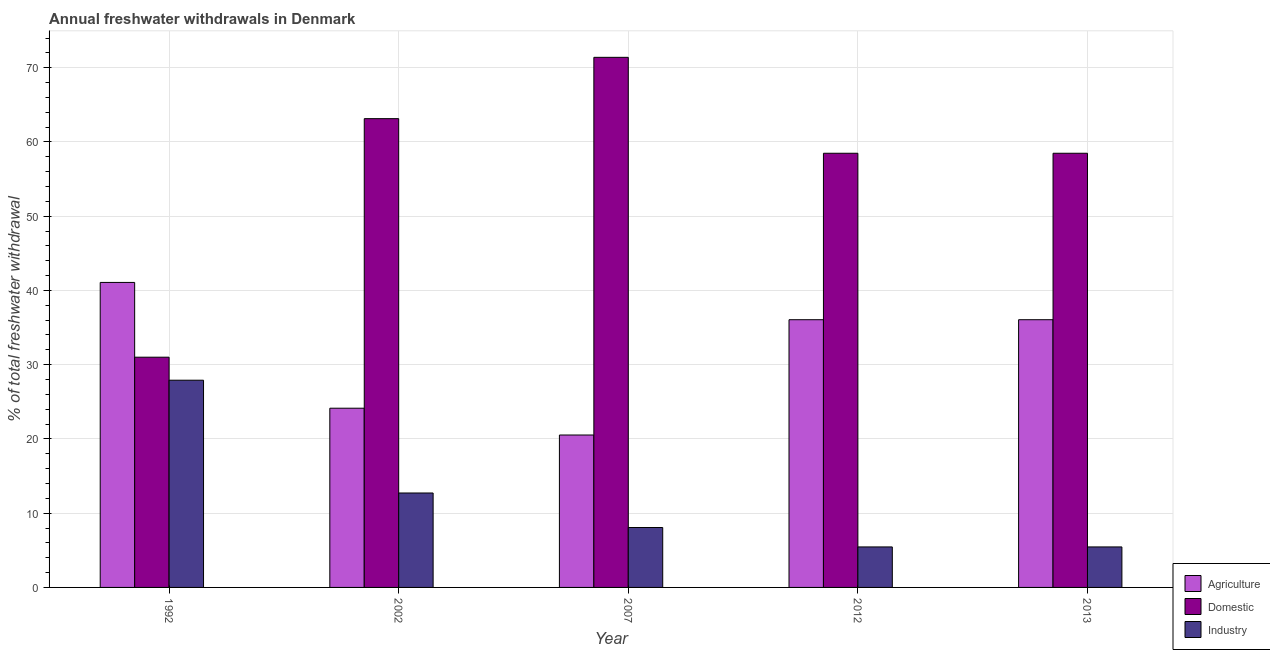How many groups of bars are there?
Provide a succinct answer. 5. Are the number of bars on each tick of the X-axis equal?
Ensure brevity in your answer.  Yes. How many bars are there on the 4th tick from the left?
Your answer should be very brief. 3. What is the label of the 1st group of bars from the left?
Your response must be concise. 1992. In how many cases, is the number of bars for a given year not equal to the number of legend labels?
Provide a succinct answer. 0. What is the percentage of freshwater withdrawal for agriculture in 2002?
Ensure brevity in your answer.  24.14. Across all years, what is the maximum percentage of freshwater withdrawal for agriculture?
Your response must be concise. 41.08. Across all years, what is the minimum percentage of freshwater withdrawal for domestic purposes?
Offer a very short reply. 31.01. In which year was the percentage of freshwater withdrawal for industry maximum?
Give a very brief answer. 1992. In which year was the percentage of freshwater withdrawal for agriculture minimum?
Offer a terse response. 2007. What is the total percentage of freshwater withdrawal for industry in the graph?
Give a very brief answer. 59.61. What is the difference between the percentage of freshwater withdrawal for domestic purposes in 2002 and that in 2012?
Ensure brevity in your answer.  4.66. What is the difference between the percentage of freshwater withdrawal for agriculture in 1992 and the percentage of freshwater withdrawal for domestic purposes in 2012?
Make the answer very short. 5.02. What is the average percentage of freshwater withdrawal for industry per year?
Give a very brief answer. 11.92. What is the ratio of the percentage of freshwater withdrawal for industry in 2007 to that in 2013?
Your response must be concise. 1.48. Is the difference between the percentage of freshwater withdrawal for agriculture in 2002 and 2013 greater than the difference between the percentage of freshwater withdrawal for industry in 2002 and 2013?
Offer a terse response. No. What is the difference between the highest and the second highest percentage of freshwater withdrawal for industry?
Keep it short and to the point. 15.19. What is the difference between the highest and the lowest percentage of freshwater withdrawal for industry?
Your answer should be compact. 22.45. What does the 3rd bar from the left in 2013 represents?
Provide a short and direct response. Industry. What does the 3rd bar from the right in 2002 represents?
Ensure brevity in your answer.  Agriculture. How many bars are there?
Provide a short and direct response. 15. Are all the bars in the graph horizontal?
Provide a succinct answer. No. How many years are there in the graph?
Offer a terse response. 5. Are the values on the major ticks of Y-axis written in scientific E-notation?
Your response must be concise. No. Does the graph contain grids?
Make the answer very short. Yes. Where does the legend appear in the graph?
Make the answer very short. Bottom right. How many legend labels are there?
Provide a short and direct response. 3. What is the title of the graph?
Give a very brief answer. Annual freshwater withdrawals in Denmark. Does "Non-communicable diseases" appear as one of the legend labels in the graph?
Give a very brief answer. No. What is the label or title of the Y-axis?
Provide a short and direct response. % of total freshwater withdrawal. What is the % of total freshwater withdrawal in Agriculture in 1992?
Provide a succinct answer. 41.08. What is the % of total freshwater withdrawal of Domestic in 1992?
Offer a terse response. 31.01. What is the % of total freshwater withdrawal of Industry in 1992?
Ensure brevity in your answer.  27.91. What is the % of total freshwater withdrawal in Agriculture in 2002?
Offer a terse response. 24.14. What is the % of total freshwater withdrawal of Domestic in 2002?
Offer a terse response. 63.14. What is the % of total freshwater withdrawal of Industry in 2002?
Offer a terse response. 12.72. What is the % of total freshwater withdrawal of Agriculture in 2007?
Provide a short and direct response. 20.53. What is the % of total freshwater withdrawal in Domestic in 2007?
Ensure brevity in your answer.  71.4. What is the % of total freshwater withdrawal in Industry in 2007?
Make the answer very short. 8.07. What is the % of total freshwater withdrawal of Agriculture in 2012?
Provide a succinct answer. 36.06. What is the % of total freshwater withdrawal of Domestic in 2012?
Make the answer very short. 58.48. What is the % of total freshwater withdrawal of Industry in 2012?
Provide a succinct answer. 5.46. What is the % of total freshwater withdrawal in Agriculture in 2013?
Your answer should be compact. 36.06. What is the % of total freshwater withdrawal of Domestic in 2013?
Offer a terse response. 58.48. What is the % of total freshwater withdrawal of Industry in 2013?
Offer a very short reply. 5.46. Across all years, what is the maximum % of total freshwater withdrawal of Agriculture?
Offer a very short reply. 41.08. Across all years, what is the maximum % of total freshwater withdrawal of Domestic?
Your answer should be compact. 71.4. Across all years, what is the maximum % of total freshwater withdrawal in Industry?
Make the answer very short. 27.91. Across all years, what is the minimum % of total freshwater withdrawal in Agriculture?
Keep it short and to the point. 20.53. Across all years, what is the minimum % of total freshwater withdrawal in Domestic?
Your response must be concise. 31.01. Across all years, what is the minimum % of total freshwater withdrawal of Industry?
Offer a very short reply. 5.46. What is the total % of total freshwater withdrawal in Agriculture in the graph?
Ensure brevity in your answer.  157.87. What is the total % of total freshwater withdrawal of Domestic in the graph?
Offer a very short reply. 282.51. What is the total % of total freshwater withdrawal in Industry in the graph?
Offer a very short reply. 59.61. What is the difference between the % of total freshwater withdrawal in Agriculture in 1992 and that in 2002?
Your response must be concise. 16.94. What is the difference between the % of total freshwater withdrawal in Domestic in 1992 and that in 2002?
Your answer should be very brief. -32.13. What is the difference between the % of total freshwater withdrawal in Industry in 1992 and that in 2002?
Your answer should be very brief. 15.19. What is the difference between the % of total freshwater withdrawal in Agriculture in 1992 and that in 2007?
Provide a succinct answer. 20.55. What is the difference between the % of total freshwater withdrawal in Domestic in 1992 and that in 2007?
Offer a very short reply. -40.39. What is the difference between the % of total freshwater withdrawal of Industry in 1992 and that in 2007?
Provide a succinct answer. 19.84. What is the difference between the % of total freshwater withdrawal of Agriculture in 1992 and that in 2012?
Provide a short and direct response. 5.02. What is the difference between the % of total freshwater withdrawal in Domestic in 1992 and that in 2012?
Your answer should be compact. -27.47. What is the difference between the % of total freshwater withdrawal of Industry in 1992 and that in 2012?
Provide a short and direct response. 22.45. What is the difference between the % of total freshwater withdrawal of Agriculture in 1992 and that in 2013?
Your response must be concise. 5.02. What is the difference between the % of total freshwater withdrawal in Domestic in 1992 and that in 2013?
Provide a succinct answer. -27.47. What is the difference between the % of total freshwater withdrawal of Industry in 1992 and that in 2013?
Your answer should be very brief. 22.45. What is the difference between the % of total freshwater withdrawal in Agriculture in 2002 and that in 2007?
Offer a terse response. 3.61. What is the difference between the % of total freshwater withdrawal of Domestic in 2002 and that in 2007?
Provide a succinct answer. -8.26. What is the difference between the % of total freshwater withdrawal in Industry in 2002 and that in 2007?
Give a very brief answer. 4.65. What is the difference between the % of total freshwater withdrawal of Agriculture in 2002 and that in 2012?
Keep it short and to the point. -11.92. What is the difference between the % of total freshwater withdrawal of Domestic in 2002 and that in 2012?
Make the answer very short. 4.66. What is the difference between the % of total freshwater withdrawal in Industry in 2002 and that in 2012?
Your answer should be compact. 7.26. What is the difference between the % of total freshwater withdrawal in Agriculture in 2002 and that in 2013?
Your response must be concise. -11.92. What is the difference between the % of total freshwater withdrawal of Domestic in 2002 and that in 2013?
Provide a succinct answer. 4.66. What is the difference between the % of total freshwater withdrawal in Industry in 2002 and that in 2013?
Provide a succinct answer. 7.26. What is the difference between the % of total freshwater withdrawal in Agriculture in 2007 and that in 2012?
Give a very brief answer. -15.53. What is the difference between the % of total freshwater withdrawal of Domestic in 2007 and that in 2012?
Give a very brief answer. 12.92. What is the difference between the % of total freshwater withdrawal of Industry in 2007 and that in 2012?
Your answer should be compact. 2.62. What is the difference between the % of total freshwater withdrawal in Agriculture in 2007 and that in 2013?
Provide a short and direct response. -15.53. What is the difference between the % of total freshwater withdrawal of Domestic in 2007 and that in 2013?
Offer a terse response. 12.92. What is the difference between the % of total freshwater withdrawal in Industry in 2007 and that in 2013?
Your response must be concise. 2.62. What is the difference between the % of total freshwater withdrawal in Domestic in 2012 and that in 2013?
Provide a succinct answer. 0. What is the difference between the % of total freshwater withdrawal of Agriculture in 1992 and the % of total freshwater withdrawal of Domestic in 2002?
Keep it short and to the point. -22.06. What is the difference between the % of total freshwater withdrawal in Agriculture in 1992 and the % of total freshwater withdrawal in Industry in 2002?
Provide a short and direct response. 28.36. What is the difference between the % of total freshwater withdrawal of Domestic in 1992 and the % of total freshwater withdrawal of Industry in 2002?
Offer a terse response. 18.29. What is the difference between the % of total freshwater withdrawal of Agriculture in 1992 and the % of total freshwater withdrawal of Domestic in 2007?
Offer a very short reply. -30.32. What is the difference between the % of total freshwater withdrawal in Agriculture in 1992 and the % of total freshwater withdrawal in Industry in 2007?
Keep it short and to the point. 33.01. What is the difference between the % of total freshwater withdrawal in Domestic in 1992 and the % of total freshwater withdrawal in Industry in 2007?
Your answer should be compact. 22.94. What is the difference between the % of total freshwater withdrawal of Agriculture in 1992 and the % of total freshwater withdrawal of Domestic in 2012?
Your answer should be compact. -17.4. What is the difference between the % of total freshwater withdrawal in Agriculture in 1992 and the % of total freshwater withdrawal in Industry in 2012?
Provide a short and direct response. 35.62. What is the difference between the % of total freshwater withdrawal in Domestic in 1992 and the % of total freshwater withdrawal in Industry in 2012?
Provide a short and direct response. 25.55. What is the difference between the % of total freshwater withdrawal of Agriculture in 1992 and the % of total freshwater withdrawal of Domestic in 2013?
Your answer should be very brief. -17.4. What is the difference between the % of total freshwater withdrawal of Agriculture in 1992 and the % of total freshwater withdrawal of Industry in 2013?
Give a very brief answer. 35.62. What is the difference between the % of total freshwater withdrawal of Domestic in 1992 and the % of total freshwater withdrawal of Industry in 2013?
Your answer should be compact. 25.55. What is the difference between the % of total freshwater withdrawal of Agriculture in 2002 and the % of total freshwater withdrawal of Domestic in 2007?
Make the answer very short. -47.26. What is the difference between the % of total freshwater withdrawal in Agriculture in 2002 and the % of total freshwater withdrawal in Industry in 2007?
Your answer should be compact. 16.07. What is the difference between the % of total freshwater withdrawal of Domestic in 2002 and the % of total freshwater withdrawal of Industry in 2007?
Your answer should be very brief. 55.07. What is the difference between the % of total freshwater withdrawal of Agriculture in 2002 and the % of total freshwater withdrawal of Domestic in 2012?
Make the answer very short. -34.34. What is the difference between the % of total freshwater withdrawal in Agriculture in 2002 and the % of total freshwater withdrawal in Industry in 2012?
Your response must be concise. 18.68. What is the difference between the % of total freshwater withdrawal of Domestic in 2002 and the % of total freshwater withdrawal of Industry in 2012?
Your answer should be very brief. 57.69. What is the difference between the % of total freshwater withdrawal in Agriculture in 2002 and the % of total freshwater withdrawal in Domestic in 2013?
Your answer should be compact. -34.34. What is the difference between the % of total freshwater withdrawal in Agriculture in 2002 and the % of total freshwater withdrawal in Industry in 2013?
Offer a terse response. 18.68. What is the difference between the % of total freshwater withdrawal in Domestic in 2002 and the % of total freshwater withdrawal in Industry in 2013?
Make the answer very short. 57.69. What is the difference between the % of total freshwater withdrawal of Agriculture in 2007 and the % of total freshwater withdrawal of Domestic in 2012?
Keep it short and to the point. -37.95. What is the difference between the % of total freshwater withdrawal in Agriculture in 2007 and the % of total freshwater withdrawal in Industry in 2012?
Provide a short and direct response. 15.07. What is the difference between the % of total freshwater withdrawal of Domestic in 2007 and the % of total freshwater withdrawal of Industry in 2012?
Your response must be concise. 65.94. What is the difference between the % of total freshwater withdrawal in Agriculture in 2007 and the % of total freshwater withdrawal in Domestic in 2013?
Provide a short and direct response. -37.95. What is the difference between the % of total freshwater withdrawal in Agriculture in 2007 and the % of total freshwater withdrawal in Industry in 2013?
Your answer should be very brief. 15.07. What is the difference between the % of total freshwater withdrawal of Domestic in 2007 and the % of total freshwater withdrawal of Industry in 2013?
Your answer should be compact. 65.94. What is the difference between the % of total freshwater withdrawal in Agriculture in 2012 and the % of total freshwater withdrawal in Domestic in 2013?
Give a very brief answer. -22.42. What is the difference between the % of total freshwater withdrawal in Agriculture in 2012 and the % of total freshwater withdrawal in Industry in 2013?
Keep it short and to the point. 30.61. What is the difference between the % of total freshwater withdrawal of Domestic in 2012 and the % of total freshwater withdrawal of Industry in 2013?
Your answer should be very brief. 53.02. What is the average % of total freshwater withdrawal in Agriculture per year?
Keep it short and to the point. 31.57. What is the average % of total freshwater withdrawal of Domestic per year?
Your response must be concise. 56.5. What is the average % of total freshwater withdrawal in Industry per year?
Offer a terse response. 11.92. In the year 1992, what is the difference between the % of total freshwater withdrawal of Agriculture and % of total freshwater withdrawal of Domestic?
Give a very brief answer. 10.07. In the year 1992, what is the difference between the % of total freshwater withdrawal in Agriculture and % of total freshwater withdrawal in Industry?
Ensure brevity in your answer.  13.17. In the year 2002, what is the difference between the % of total freshwater withdrawal of Agriculture and % of total freshwater withdrawal of Domestic?
Your answer should be very brief. -39. In the year 2002, what is the difference between the % of total freshwater withdrawal of Agriculture and % of total freshwater withdrawal of Industry?
Provide a succinct answer. 11.42. In the year 2002, what is the difference between the % of total freshwater withdrawal in Domestic and % of total freshwater withdrawal in Industry?
Keep it short and to the point. 50.42. In the year 2007, what is the difference between the % of total freshwater withdrawal of Agriculture and % of total freshwater withdrawal of Domestic?
Provide a succinct answer. -50.87. In the year 2007, what is the difference between the % of total freshwater withdrawal of Agriculture and % of total freshwater withdrawal of Industry?
Ensure brevity in your answer.  12.46. In the year 2007, what is the difference between the % of total freshwater withdrawal of Domestic and % of total freshwater withdrawal of Industry?
Provide a succinct answer. 63.33. In the year 2012, what is the difference between the % of total freshwater withdrawal in Agriculture and % of total freshwater withdrawal in Domestic?
Your answer should be compact. -22.42. In the year 2012, what is the difference between the % of total freshwater withdrawal of Agriculture and % of total freshwater withdrawal of Industry?
Make the answer very short. 30.61. In the year 2012, what is the difference between the % of total freshwater withdrawal in Domestic and % of total freshwater withdrawal in Industry?
Offer a very short reply. 53.02. In the year 2013, what is the difference between the % of total freshwater withdrawal in Agriculture and % of total freshwater withdrawal in Domestic?
Give a very brief answer. -22.42. In the year 2013, what is the difference between the % of total freshwater withdrawal of Agriculture and % of total freshwater withdrawal of Industry?
Provide a succinct answer. 30.61. In the year 2013, what is the difference between the % of total freshwater withdrawal in Domestic and % of total freshwater withdrawal in Industry?
Provide a succinct answer. 53.02. What is the ratio of the % of total freshwater withdrawal of Agriculture in 1992 to that in 2002?
Your answer should be very brief. 1.7. What is the ratio of the % of total freshwater withdrawal in Domestic in 1992 to that in 2002?
Your answer should be compact. 0.49. What is the ratio of the % of total freshwater withdrawal of Industry in 1992 to that in 2002?
Offer a terse response. 2.19. What is the ratio of the % of total freshwater withdrawal in Agriculture in 1992 to that in 2007?
Offer a terse response. 2. What is the ratio of the % of total freshwater withdrawal of Domestic in 1992 to that in 2007?
Provide a short and direct response. 0.43. What is the ratio of the % of total freshwater withdrawal in Industry in 1992 to that in 2007?
Your response must be concise. 3.46. What is the ratio of the % of total freshwater withdrawal in Agriculture in 1992 to that in 2012?
Your answer should be compact. 1.14. What is the ratio of the % of total freshwater withdrawal in Domestic in 1992 to that in 2012?
Provide a succinct answer. 0.53. What is the ratio of the % of total freshwater withdrawal in Industry in 1992 to that in 2012?
Your answer should be very brief. 5.12. What is the ratio of the % of total freshwater withdrawal in Agriculture in 1992 to that in 2013?
Make the answer very short. 1.14. What is the ratio of the % of total freshwater withdrawal in Domestic in 1992 to that in 2013?
Ensure brevity in your answer.  0.53. What is the ratio of the % of total freshwater withdrawal in Industry in 1992 to that in 2013?
Provide a short and direct response. 5.12. What is the ratio of the % of total freshwater withdrawal in Agriculture in 2002 to that in 2007?
Offer a very short reply. 1.18. What is the ratio of the % of total freshwater withdrawal of Domestic in 2002 to that in 2007?
Provide a succinct answer. 0.88. What is the ratio of the % of total freshwater withdrawal in Industry in 2002 to that in 2007?
Make the answer very short. 1.58. What is the ratio of the % of total freshwater withdrawal of Agriculture in 2002 to that in 2012?
Make the answer very short. 0.67. What is the ratio of the % of total freshwater withdrawal in Domestic in 2002 to that in 2012?
Your answer should be compact. 1.08. What is the ratio of the % of total freshwater withdrawal of Industry in 2002 to that in 2012?
Offer a very short reply. 2.33. What is the ratio of the % of total freshwater withdrawal in Agriculture in 2002 to that in 2013?
Provide a short and direct response. 0.67. What is the ratio of the % of total freshwater withdrawal of Domestic in 2002 to that in 2013?
Keep it short and to the point. 1.08. What is the ratio of the % of total freshwater withdrawal in Industry in 2002 to that in 2013?
Make the answer very short. 2.33. What is the ratio of the % of total freshwater withdrawal in Agriculture in 2007 to that in 2012?
Ensure brevity in your answer.  0.57. What is the ratio of the % of total freshwater withdrawal of Domestic in 2007 to that in 2012?
Make the answer very short. 1.22. What is the ratio of the % of total freshwater withdrawal of Industry in 2007 to that in 2012?
Provide a short and direct response. 1.48. What is the ratio of the % of total freshwater withdrawal of Agriculture in 2007 to that in 2013?
Your answer should be compact. 0.57. What is the ratio of the % of total freshwater withdrawal of Domestic in 2007 to that in 2013?
Offer a terse response. 1.22. What is the ratio of the % of total freshwater withdrawal of Industry in 2007 to that in 2013?
Your answer should be very brief. 1.48. What is the ratio of the % of total freshwater withdrawal in Agriculture in 2012 to that in 2013?
Provide a short and direct response. 1. What is the ratio of the % of total freshwater withdrawal in Domestic in 2012 to that in 2013?
Provide a short and direct response. 1. What is the difference between the highest and the second highest % of total freshwater withdrawal of Agriculture?
Give a very brief answer. 5.02. What is the difference between the highest and the second highest % of total freshwater withdrawal of Domestic?
Provide a succinct answer. 8.26. What is the difference between the highest and the second highest % of total freshwater withdrawal in Industry?
Your answer should be compact. 15.19. What is the difference between the highest and the lowest % of total freshwater withdrawal of Agriculture?
Offer a very short reply. 20.55. What is the difference between the highest and the lowest % of total freshwater withdrawal in Domestic?
Give a very brief answer. 40.39. What is the difference between the highest and the lowest % of total freshwater withdrawal of Industry?
Provide a short and direct response. 22.45. 